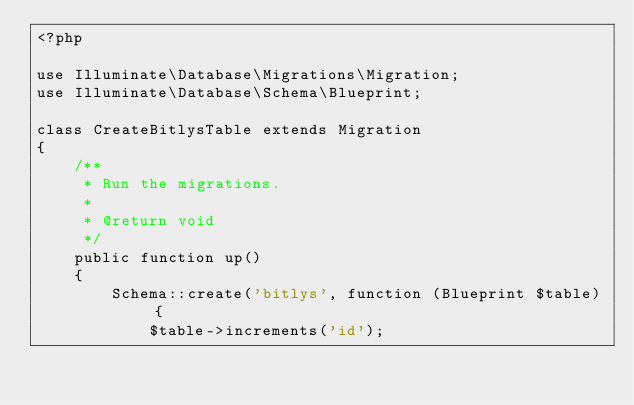<code> <loc_0><loc_0><loc_500><loc_500><_PHP_><?php

use Illuminate\Database\Migrations\Migration;
use Illuminate\Database\Schema\Blueprint;

class CreateBitlysTable extends Migration
{
    /**
     * Run the migrations.
     *
     * @return void
     */
    public function up()
    {
        Schema::create('bitlys', function (Blueprint $table) {
            $table->increments('id');</code> 